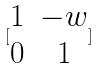<formula> <loc_0><loc_0><loc_500><loc_500>[ \begin{matrix} 1 & - w \\ 0 & 1 \end{matrix} ]</formula> 